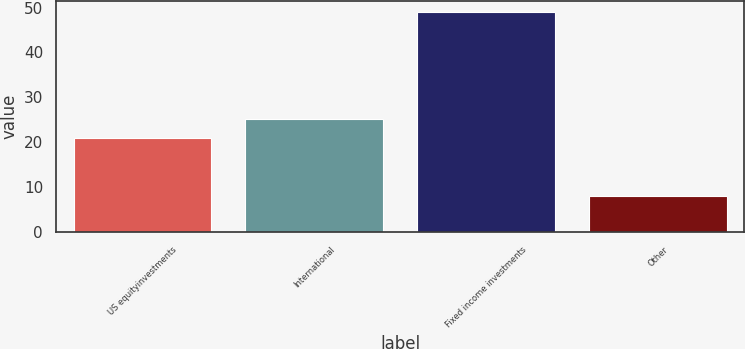Convert chart to OTSL. <chart><loc_0><loc_0><loc_500><loc_500><bar_chart><fcel>US equityinvestments<fcel>International<fcel>Fixed income investments<fcel>Other<nl><fcel>21<fcel>25.1<fcel>49<fcel>8<nl></chart> 